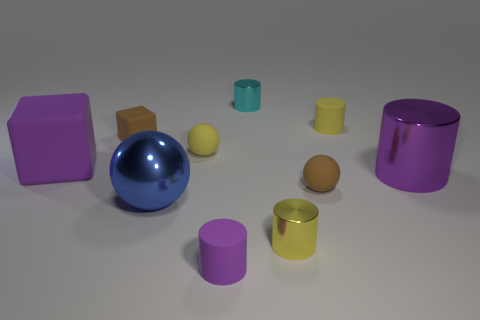Is the color of the large thing that is to the left of the blue metallic object the same as the big shiny cylinder?
Provide a succinct answer. Yes. What number of objects are either objects on the left side of the yellow shiny cylinder or small cyan matte cubes?
Provide a succinct answer. 6. Is the number of yellow objects in front of the purple cube greater than the number of purple cylinders that are in front of the purple rubber cylinder?
Provide a succinct answer. Yes. Is the tiny brown block made of the same material as the small purple cylinder?
Keep it short and to the point. Yes. There is a shiny thing that is on the right side of the small cyan shiny cylinder and left of the purple shiny cylinder; what shape is it?
Your response must be concise. Cylinder. What is the shape of the big purple object that is the same material as the brown ball?
Provide a succinct answer. Cube. Are there any tiny gray objects?
Provide a short and direct response. No. There is a small metallic thing in front of the purple metallic thing; are there any metallic cylinders that are behind it?
Provide a succinct answer. Yes. What material is the large purple thing that is the same shape as the small yellow metallic thing?
Your response must be concise. Metal. Is the number of small yellow objects greater than the number of objects?
Offer a terse response. No. 